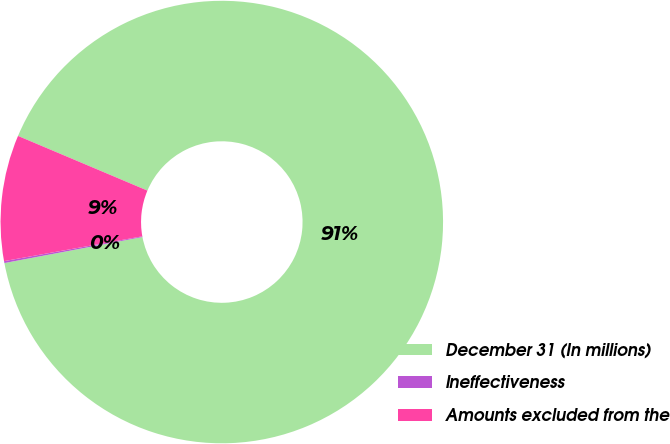Convert chart to OTSL. <chart><loc_0><loc_0><loc_500><loc_500><pie_chart><fcel>December 31 (In millions)<fcel>Ineffectiveness<fcel>Amounts excluded from the<nl><fcel>90.67%<fcel>0.14%<fcel>9.19%<nl></chart> 